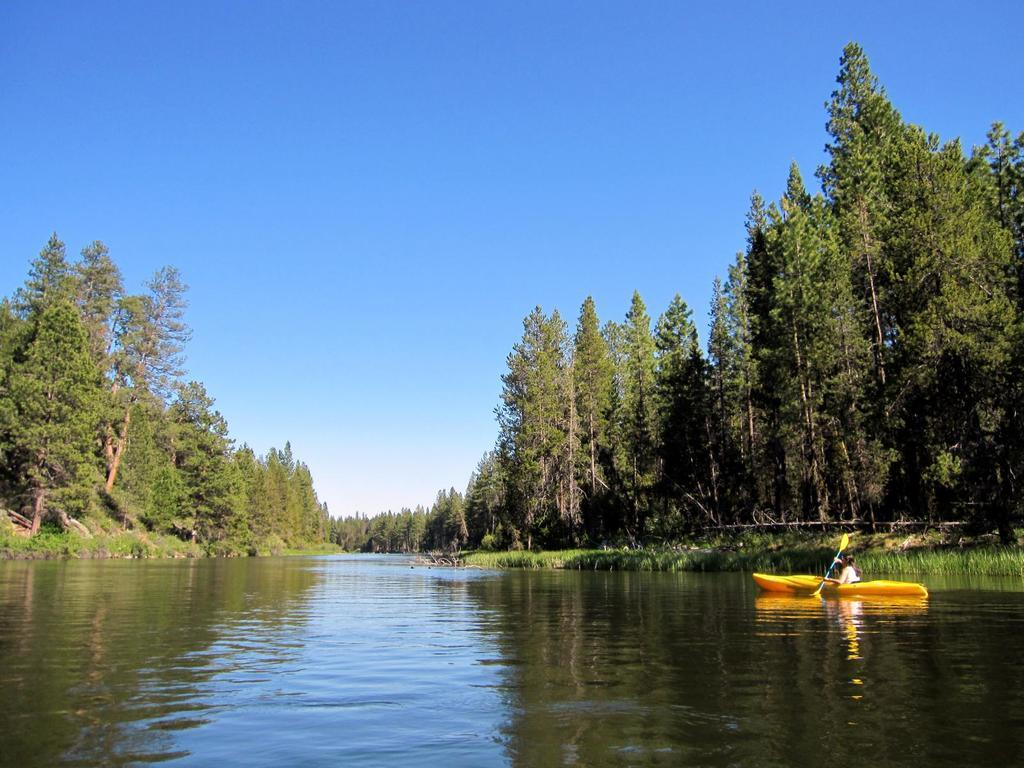What is the person in the image doing? The person is sitting on a boat. What is the person holding while sitting on the boat? The person is holding a pedal. What can be seen beneath the boat in the image? There is water visible in the image. What type of natural environment is visible in the background of the image? There are trees and grass in the background of the image. What is the color of the sky in the image? The sky is blue in color. What type of fuel is being used by the boat in the image? The facts provided do not mention any information about the type of fuel being used by the boat. Therefore, we cannot determine the type of fuel being used from the image. 